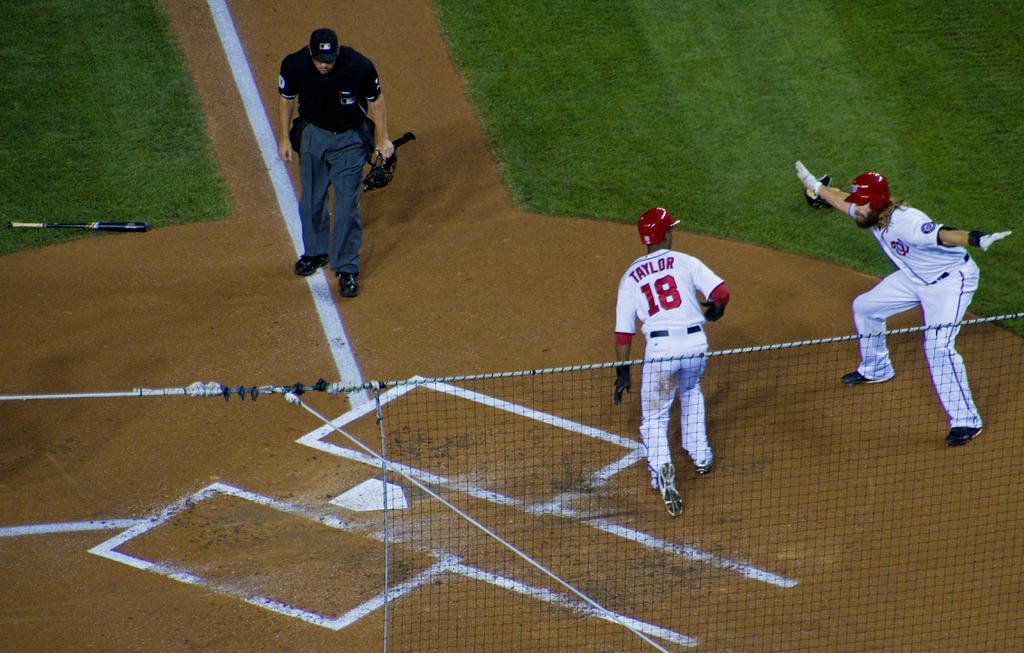Please provide a concise description of this image. This picture is taken on the ground. Towards the right, there are two men wearing white t shirts, white trousers and red helmets. On the top left, there is a man wearing a black t shirt, grey trousers and a black cap and he is holding something. At the bottom, there is a net. Towards the left, there is a bat on the ground. 